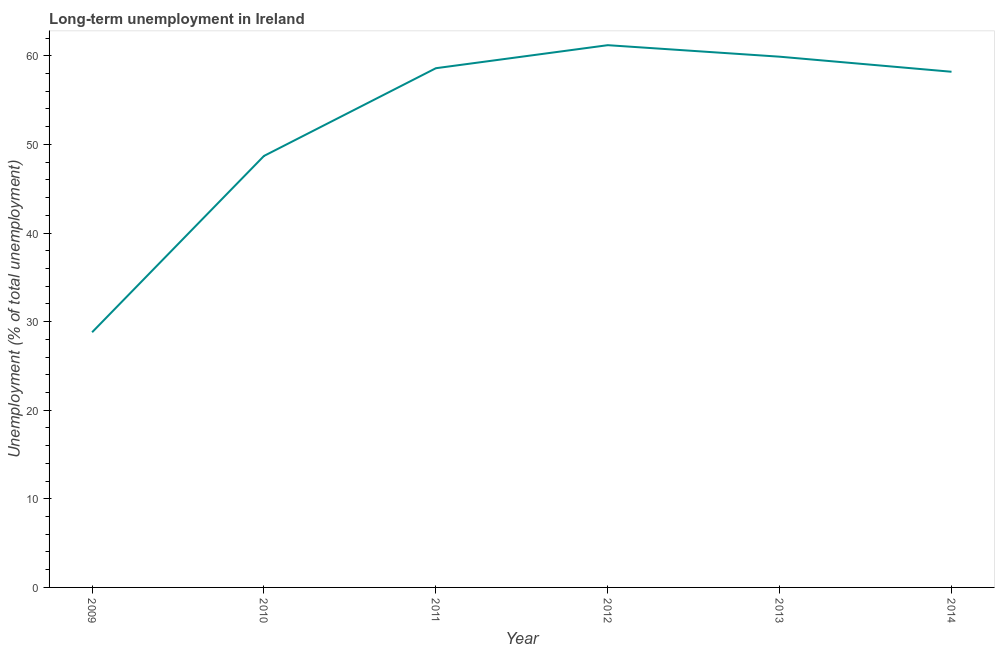What is the long-term unemployment in 2009?
Keep it short and to the point. 28.8. Across all years, what is the maximum long-term unemployment?
Offer a terse response. 61.2. Across all years, what is the minimum long-term unemployment?
Offer a terse response. 28.8. What is the sum of the long-term unemployment?
Your answer should be compact. 315.4. What is the difference between the long-term unemployment in 2012 and 2014?
Your answer should be very brief. 3. What is the average long-term unemployment per year?
Give a very brief answer. 52.57. What is the median long-term unemployment?
Your answer should be compact. 58.4. Do a majority of the years between 2010 and 2014 (inclusive) have long-term unemployment greater than 50 %?
Offer a terse response. Yes. What is the ratio of the long-term unemployment in 2012 to that in 2014?
Make the answer very short. 1.05. What is the difference between the highest and the second highest long-term unemployment?
Make the answer very short. 1.3. Is the sum of the long-term unemployment in 2010 and 2011 greater than the maximum long-term unemployment across all years?
Your answer should be compact. Yes. What is the difference between the highest and the lowest long-term unemployment?
Make the answer very short. 32.4. In how many years, is the long-term unemployment greater than the average long-term unemployment taken over all years?
Offer a terse response. 4. What is the difference between two consecutive major ticks on the Y-axis?
Offer a terse response. 10. Are the values on the major ticks of Y-axis written in scientific E-notation?
Your answer should be compact. No. Does the graph contain any zero values?
Your answer should be compact. No. What is the title of the graph?
Make the answer very short. Long-term unemployment in Ireland. What is the label or title of the X-axis?
Your response must be concise. Year. What is the label or title of the Y-axis?
Provide a short and direct response. Unemployment (% of total unemployment). What is the Unemployment (% of total unemployment) in 2009?
Provide a succinct answer. 28.8. What is the Unemployment (% of total unemployment) in 2010?
Provide a short and direct response. 48.7. What is the Unemployment (% of total unemployment) of 2011?
Give a very brief answer. 58.6. What is the Unemployment (% of total unemployment) in 2012?
Ensure brevity in your answer.  61.2. What is the Unemployment (% of total unemployment) in 2013?
Ensure brevity in your answer.  59.9. What is the Unemployment (% of total unemployment) in 2014?
Provide a succinct answer. 58.2. What is the difference between the Unemployment (% of total unemployment) in 2009 and 2010?
Offer a terse response. -19.9. What is the difference between the Unemployment (% of total unemployment) in 2009 and 2011?
Provide a succinct answer. -29.8. What is the difference between the Unemployment (% of total unemployment) in 2009 and 2012?
Keep it short and to the point. -32.4. What is the difference between the Unemployment (% of total unemployment) in 2009 and 2013?
Provide a short and direct response. -31.1. What is the difference between the Unemployment (% of total unemployment) in 2009 and 2014?
Keep it short and to the point. -29.4. What is the difference between the Unemployment (% of total unemployment) in 2010 and 2014?
Ensure brevity in your answer.  -9.5. What is the difference between the Unemployment (% of total unemployment) in 2011 and 2014?
Your answer should be compact. 0.4. What is the difference between the Unemployment (% of total unemployment) in 2012 and 2014?
Your answer should be very brief. 3. What is the difference between the Unemployment (% of total unemployment) in 2013 and 2014?
Offer a very short reply. 1.7. What is the ratio of the Unemployment (% of total unemployment) in 2009 to that in 2010?
Keep it short and to the point. 0.59. What is the ratio of the Unemployment (% of total unemployment) in 2009 to that in 2011?
Offer a very short reply. 0.49. What is the ratio of the Unemployment (% of total unemployment) in 2009 to that in 2012?
Ensure brevity in your answer.  0.47. What is the ratio of the Unemployment (% of total unemployment) in 2009 to that in 2013?
Ensure brevity in your answer.  0.48. What is the ratio of the Unemployment (% of total unemployment) in 2009 to that in 2014?
Give a very brief answer. 0.49. What is the ratio of the Unemployment (% of total unemployment) in 2010 to that in 2011?
Your answer should be compact. 0.83. What is the ratio of the Unemployment (% of total unemployment) in 2010 to that in 2012?
Keep it short and to the point. 0.8. What is the ratio of the Unemployment (% of total unemployment) in 2010 to that in 2013?
Offer a very short reply. 0.81. What is the ratio of the Unemployment (% of total unemployment) in 2010 to that in 2014?
Provide a short and direct response. 0.84. What is the ratio of the Unemployment (% of total unemployment) in 2011 to that in 2012?
Provide a succinct answer. 0.96. What is the ratio of the Unemployment (% of total unemployment) in 2011 to that in 2013?
Your answer should be very brief. 0.98. What is the ratio of the Unemployment (% of total unemployment) in 2012 to that in 2014?
Give a very brief answer. 1.05. What is the ratio of the Unemployment (% of total unemployment) in 2013 to that in 2014?
Your answer should be compact. 1.03. 